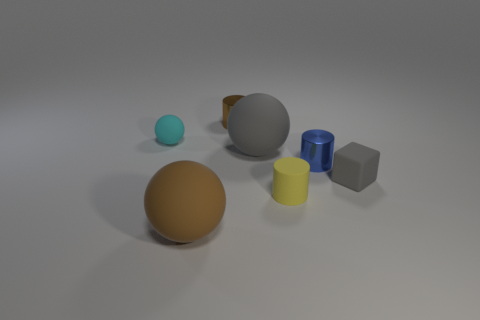Is there a blue metal object of the same shape as the small yellow matte thing?
Your answer should be very brief. Yes. Are there fewer tiny rubber objects than small things?
Your answer should be very brief. Yes. Is the size of the rubber object that is to the left of the big brown matte sphere the same as the gray ball behind the brown matte object?
Your answer should be very brief. No. What number of things are either large rubber spheres or small metal things?
Ensure brevity in your answer.  4. What is the size of the sphere that is on the right side of the big brown matte sphere?
Your answer should be very brief. Large. How many brown cylinders are left of the metal object in front of the small cylinder that is to the left of the big gray sphere?
Your answer should be compact. 1. What number of large matte balls are behind the brown rubber ball and in front of the tiny blue object?
Provide a short and direct response. 0. What is the shape of the large object that is behind the tiny gray rubber object?
Provide a short and direct response. Sphere. Is the number of small metal cylinders left of the big brown sphere less than the number of gray matte objects that are on the left side of the small blue thing?
Provide a short and direct response. Yes. Do the cylinder that is behind the small cyan ball and the cylinder right of the tiny yellow matte cylinder have the same material?
Give a very brief answer. Yes. 